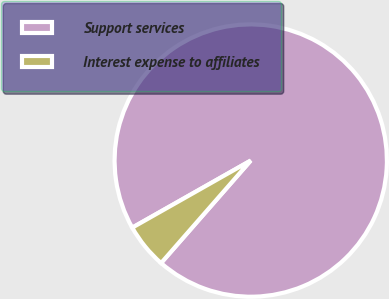Convert chart to OTSL. <chart><loc_0><loc_0><loc_500><loc_500><pie_chart><fcel>Support services<fcel>Interest expense to affiliates<nl><fcel>94.64%<fcel>5.36%<nl></chart> 